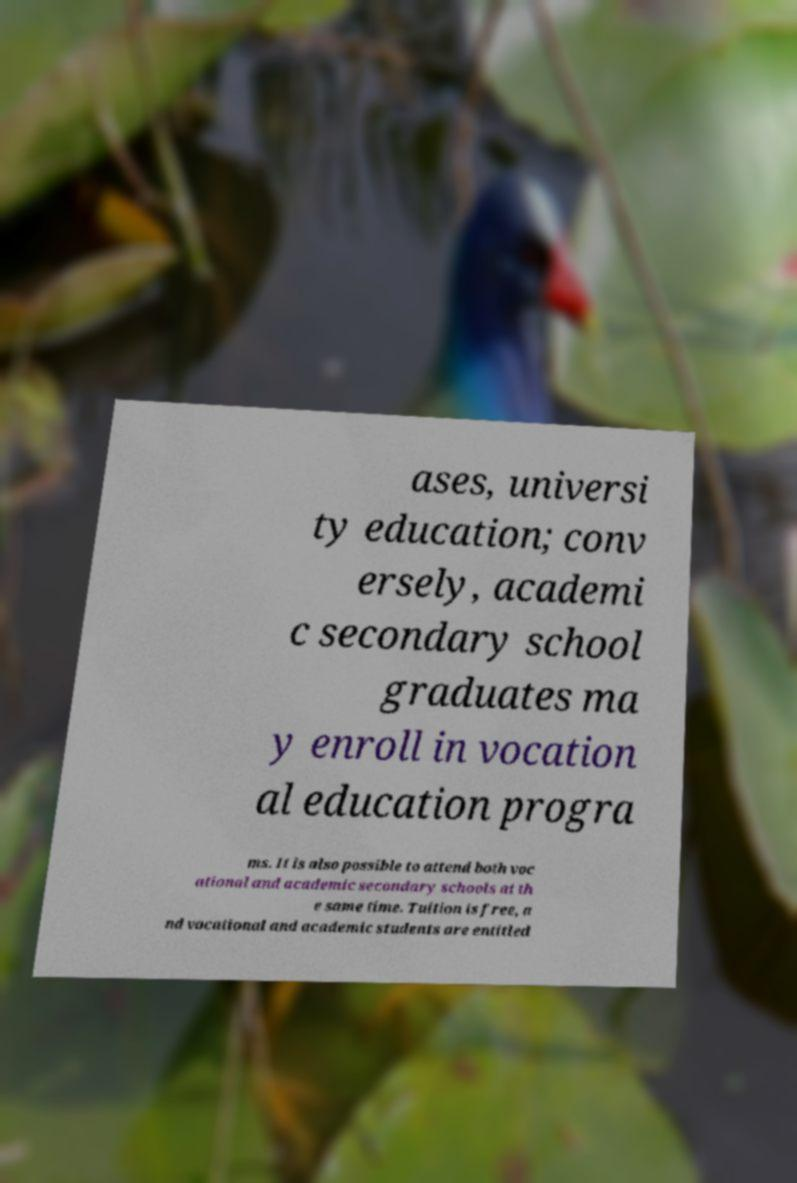Could you extract and type out the text from this image? ases, universi ty education; conv ersely, academi c secondary school graduates ma y enroll in vocation al education progra ms. It is also possible to attend both voc ational and academic secondary schools at th e same time. Tuition is free, a nd vocational and academic students are entitled 